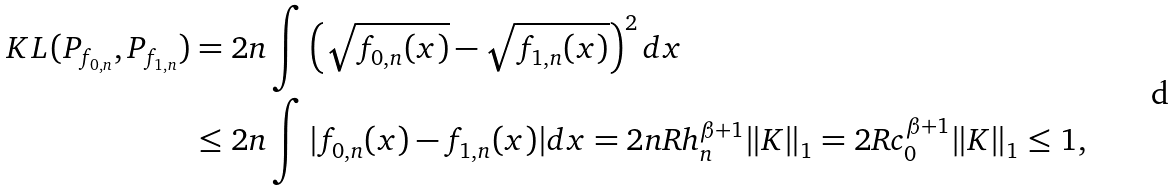Convert formula to latex. <formula><loc_0><loc_0><loc_500><loc_500>K L ( P _ { f _ { 0 , n } } , P _ { f _ { 1 , n } } ) & = 2 n \int \left ( \sqrt { f _ { 0 , n } ( x ) } - \sqrt { f _ { 1 , n } ( x ) } \right ) ^ { 2 } d x \\ & \leq 2 n \int | f _ { 0 , n } ( x ) - f _ { 1 , n } ( x ) | d x = 2 n R h _ { n } ^ { \beta + 1 } \| K \| _ { 1 } = 2 R c _ { 0 } ^ { \beta + 1 } \| K \| _ { 1 } \leq 1 ,</formula> 